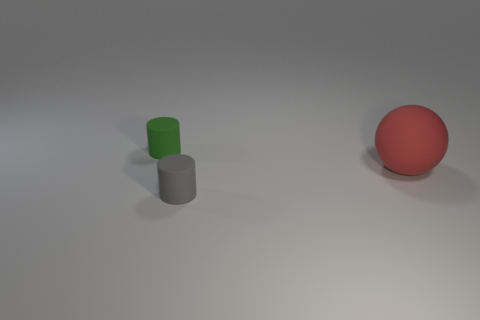What is the shape of the red thing?
Your answer should be very brief. Sphere. There is a cylinder that is on the right side of the tiny thing that is left of the small thing in front of the small green rubber cylinder; how big is it?
Your answer should be very brief. Small. What shape is the other object that is the same size as the gray rubber object?
Give a very brief answer. Cylinder. How many tiny objects are gray shiny cubes or rubber balls?
Provide a succinct answer. 0. There is a thing that is to the left of the tiny rubber cylinder in front of the large red thing; is there a thing that is behind it?
Make the answer very short. No. Are there any cylinders that have the same size as the green object?
Offer a terse response. Yes. What material is the green object that is the same size as the gray cylinder?
Make the answer very short. Rubber. There is a red object; does it have the same size as the rubber cylinder to the left of the tiny gray cylinder?
Provide a short and direct response. No. What number of metal things are large blue spheres or large red spheres?
Offer a very short reply. 0. What number of green things are the same shape as the tiny gray matte thing?
Keep it short and to the point. 1. 